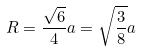<formula> <loc_0><loc_0><loc_500><loc_500>R = \frac { \sqrt { 6 } } { 4 } a = \sqrt { \frac { 3 } { 8 } } a</formula> 